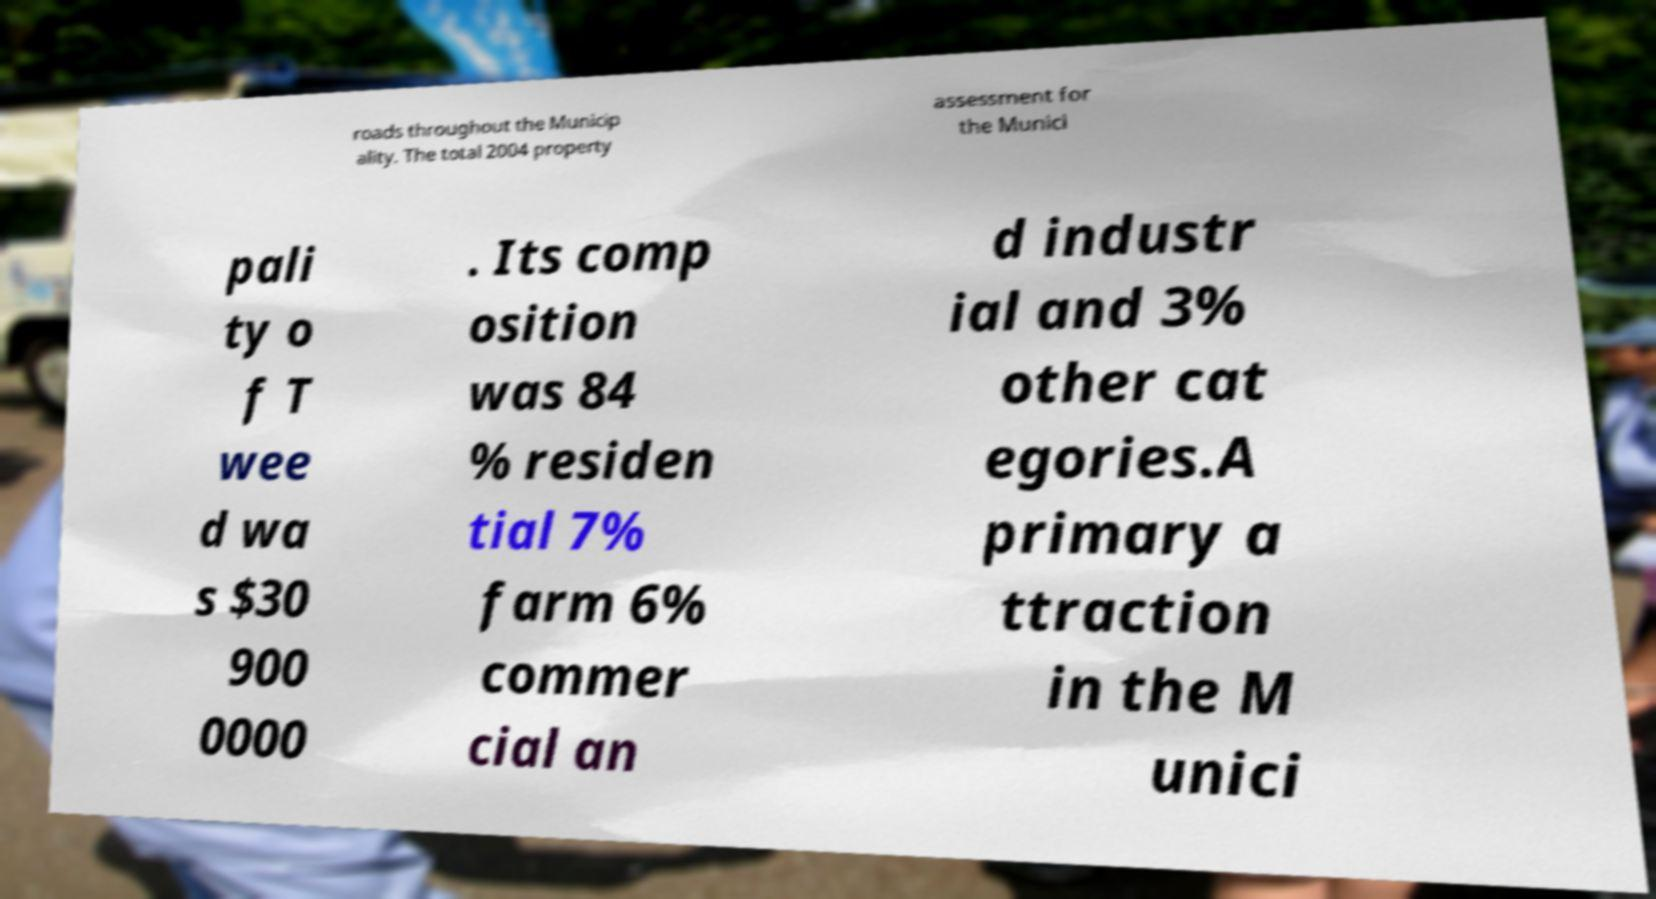Could you extract and type out the text from this image? roads throughout the Municip ality. The total 2004 property assessment for the Munici pali ty o f T wee d wa s $30 900 0000 . Its comp osition was 84 % residen tial 7% farm 6% commer cial an d industr ial and 3% other cat egories.A primary a ttraction in the M unici 